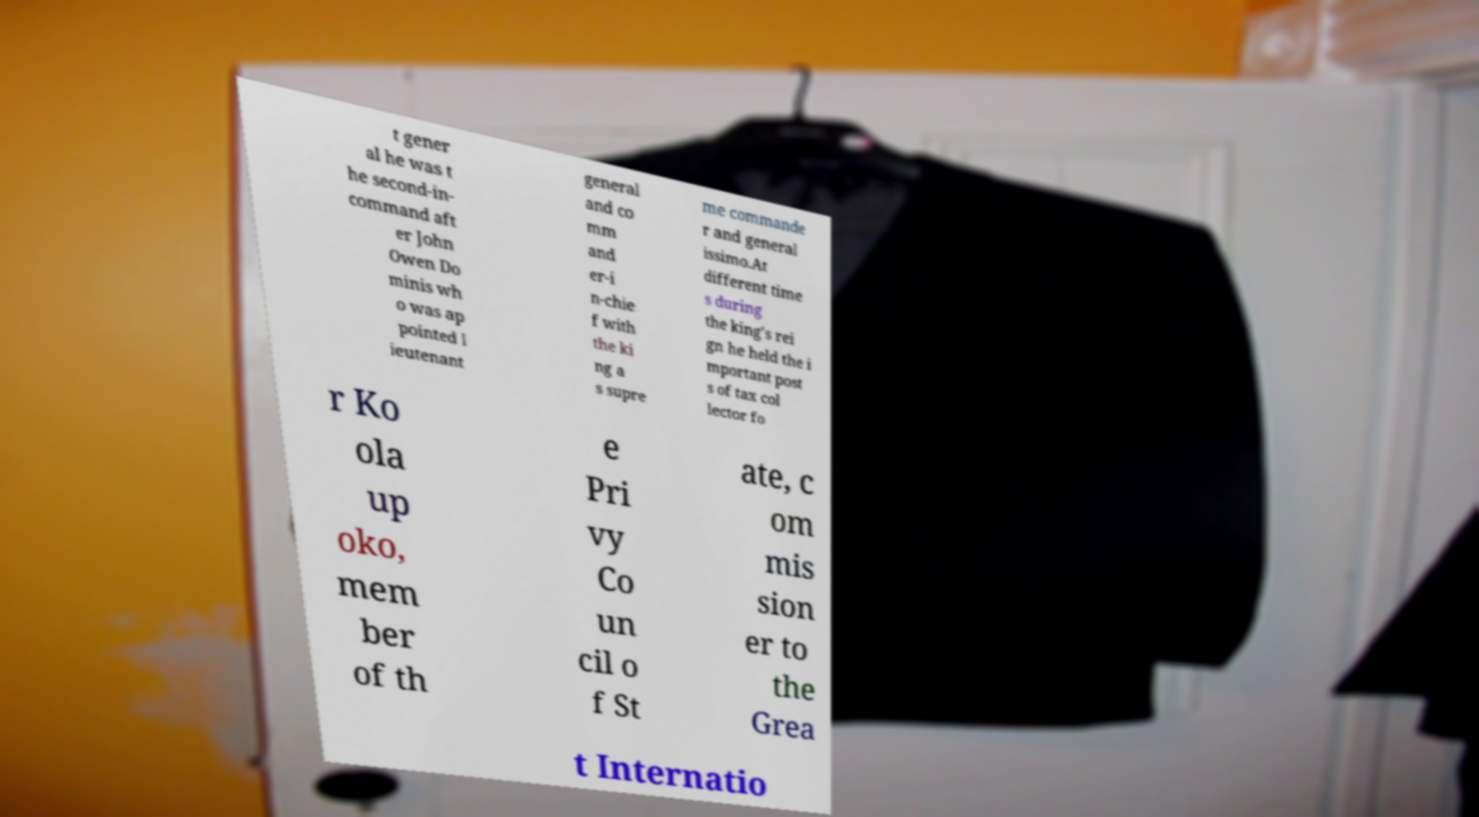Could you extract and type out the text from this image? t gener al he was t he second-in- command aft er John Owen Do minis wh o was ap pointed l ieutenant general and co mm and er-i n-chie f with the ki ng a s supre me commande r and general issimo.At different time s during the king's rei gn he held the i mportant post s of tax col lector fo r Ko ola up oko, mem ber of th e Pri vy Co un cil o f St ate, c om mis sion er to the Grea t Internatio 